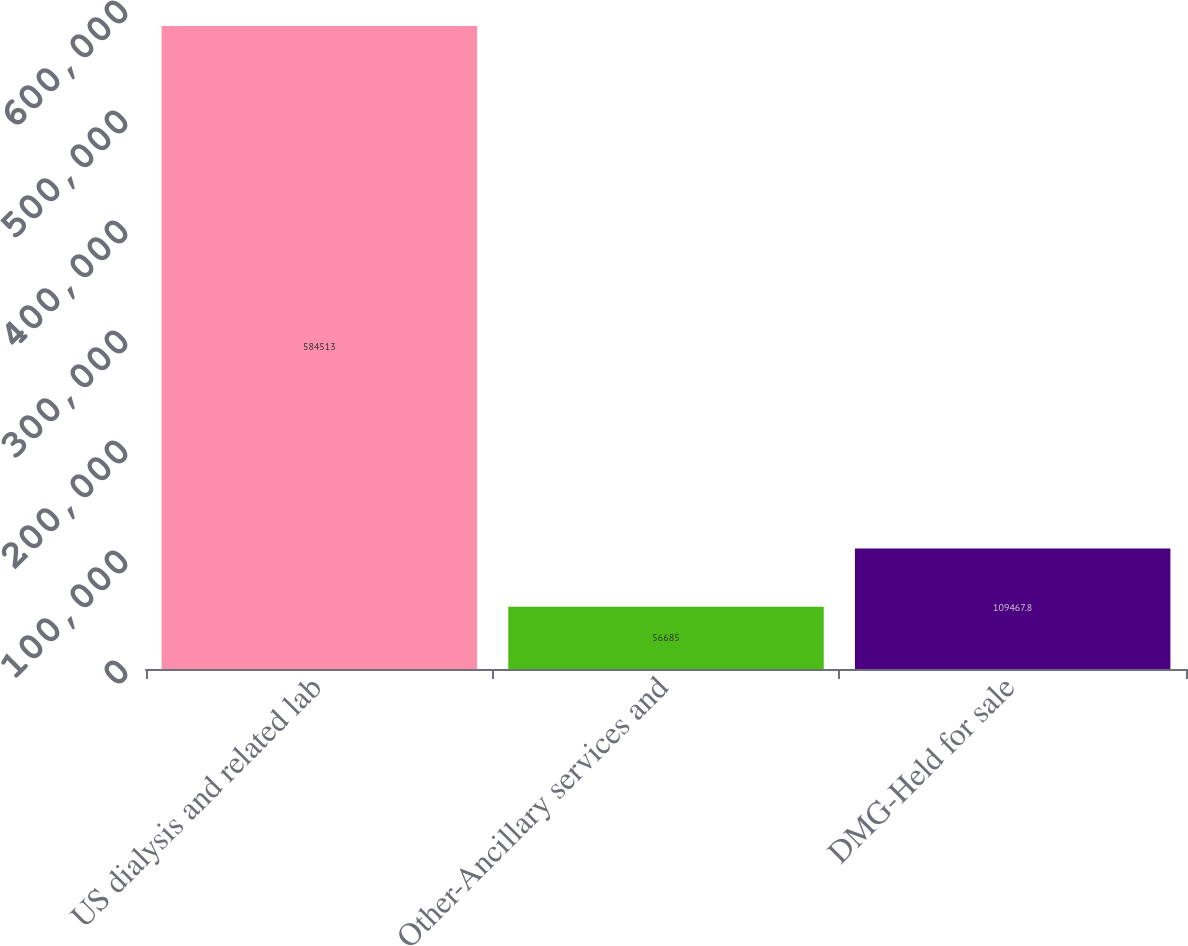Convert chart to OTSL. <chart><loc_0><loc_0><loc_500><loc_500><bar_chart><fcel>US dialysis and related lab<fcel>Other-Ancillary services and<fcel>DMG-Held for sale<nl><fcel>584513<fcel>56685<fcel>109468<nl></chart> 